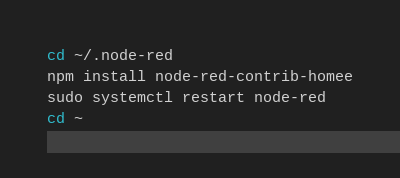Convert code to text. <code><loc_0><loc_0><loc_500><loc_500><_Bash_>
cd ~/.node-red
npm install node-red-contrib-homee
sudo systemctl restart node-red
cd ~</code> 